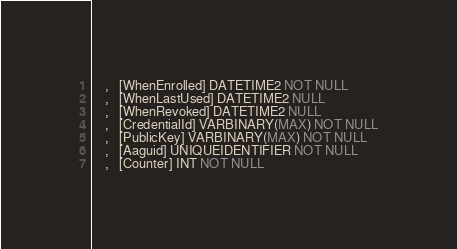<code> <loc_0><loc_0><loc_500><loc_500><_SQL_>    ,   [WhenEnrolled] DATETIME2 NOT NULL
    ,   [WhenLastUsed] DATETIME2 NULL
    ,   [WhenRevoked] DATETIME2 NULL
    ,   [CredentialId] VARBINARY(MAX) NOT NULL
    ,   [PublicKey] VARBINARY(MAX) NOT NULL
    ,   [Aaguid] UNIQUEIDENTIFIER NOT NULL
    ,   [Counter] INT NOT NULL</code> 